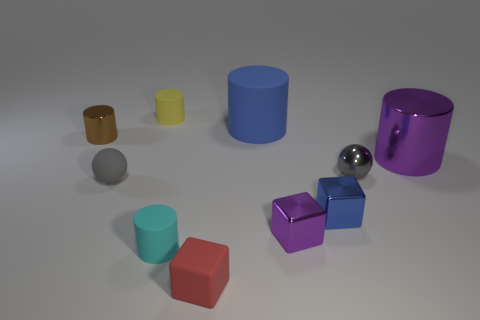What color is the big metallic object that is the same shape as the blue rubber thing?
Offer a terse response. Purple. What size is the red block that is made of the same material as the tiny yellow cylinder?
Your answer should be very brief. Small. Is the shape of the small purple object the same as the blue metal thing?
Ensure brevity in your answer.  Yes. What is the size of the brown object that is the same shape as the cyan matte object?
Ensure brevity in your answer.  Small. The small metallic thing that is the same color as the big matte thing is what shape?
Offer a terse response. Cube. What material is the yellow cylinder?
Keep it short and to the point. Rubber. There is a large object that is made of the same material as the tiny red cube; what is its shape?
Provide a succinct answer. Cylinder. There is a cylinder in front of the metallic cylinder to the right of the small yellow object; how big is it?
Keep it short and to the point. Small. There is a thing to the left of the small matte sphere; what color is it?
Provide a short and direct response. Brown. Is there a cyan matte object of the same shape as the red matte object?
Offer a very short reply. No. 